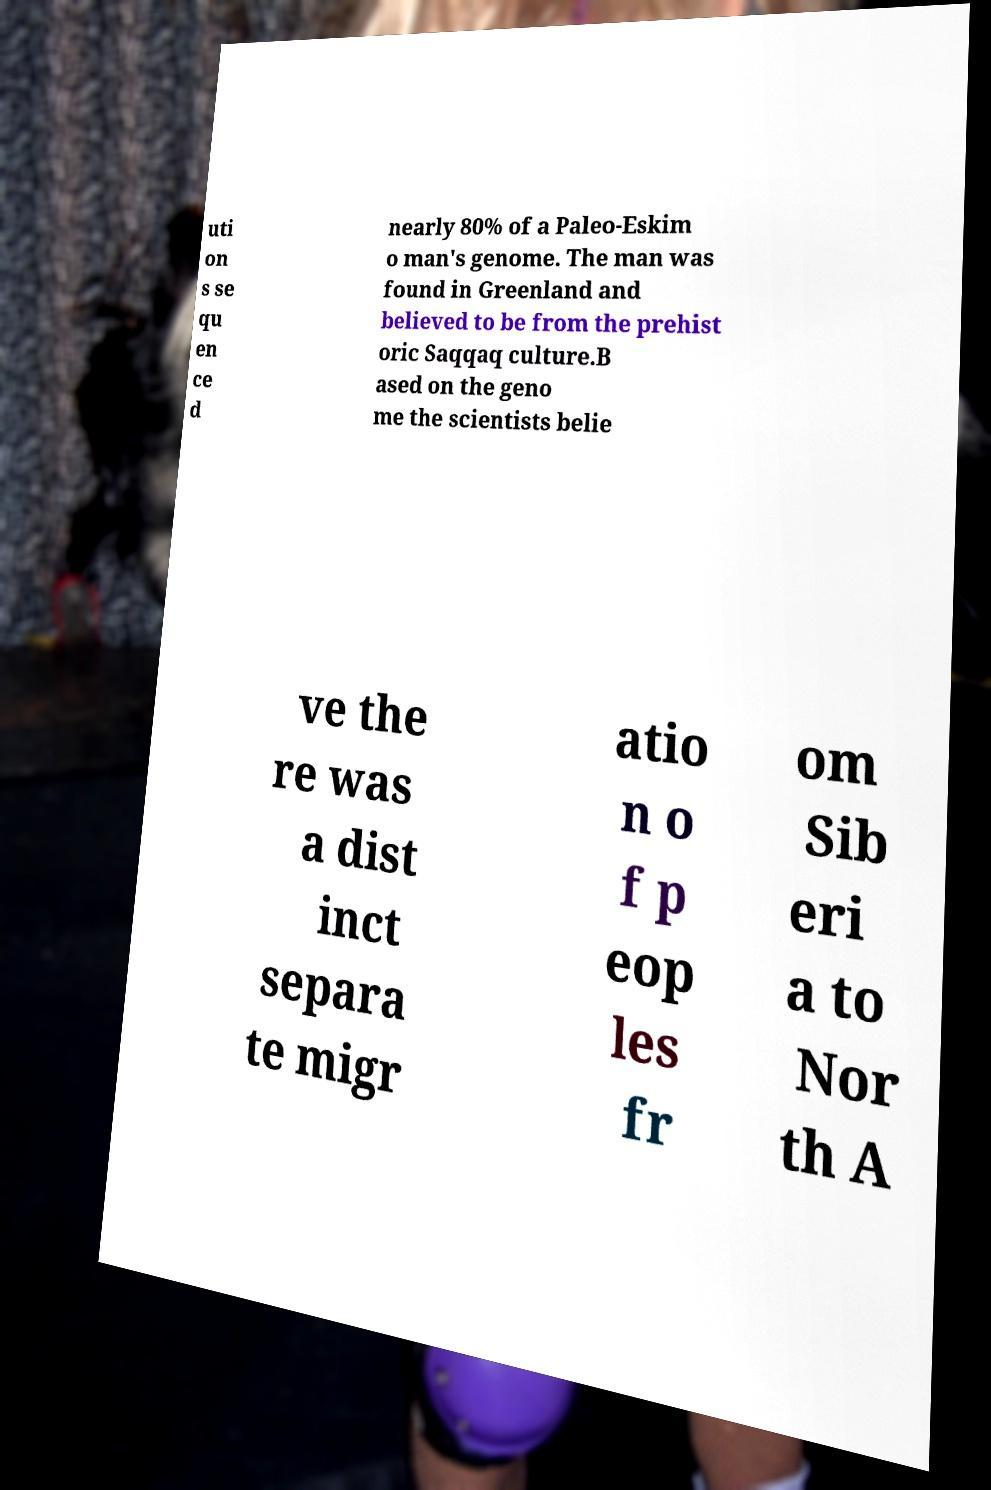What messages or text are displayed in this image? I need them in a readable, typed format. uti on s se qu en ce d nearly 80% of a Paleo-Eskim o man's genome. The man was found in Greenland and believed to be from the prehist oric Saqqaq culture.B ased on the geno me the scientists belie ve the re was a dist inct separa te migr atio n o f p eop les fr om Sib eri a to Nor th A 